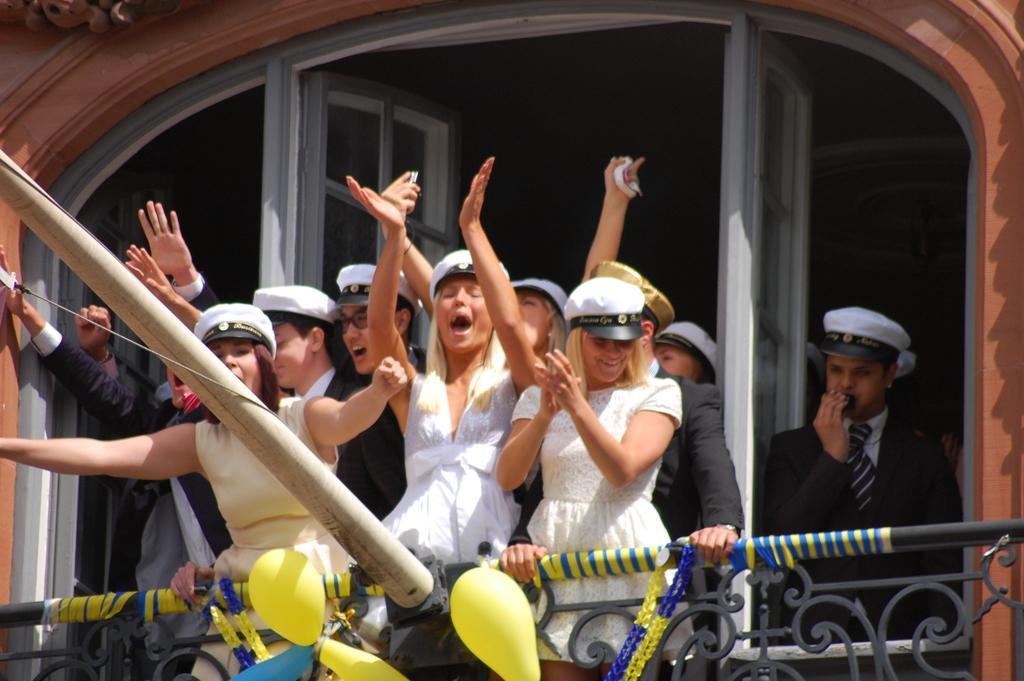Could you give a brief overview of what you see in this image? In this image, we can see people and are wearing caps and some are wearing coats and holding some objects and we can see doors and a wall. At the bottom, there is a rod and we can see balloons, streamers and a railing. 